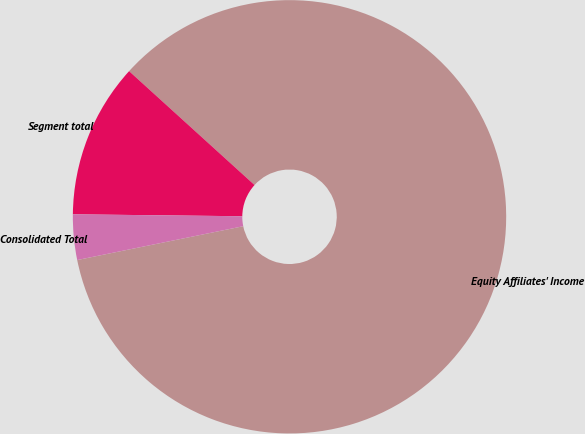Convert chart to OTSL. <chart><loc_0><loc_0><loc_500><loc_500><pie_chart><fcel>Equity Affiliates' Income<fcel>Segment total<fcel>Consolidated Total<nl><fcel>85.07%<fcel>11.55%<fcel>3.38%<nl></chart> 